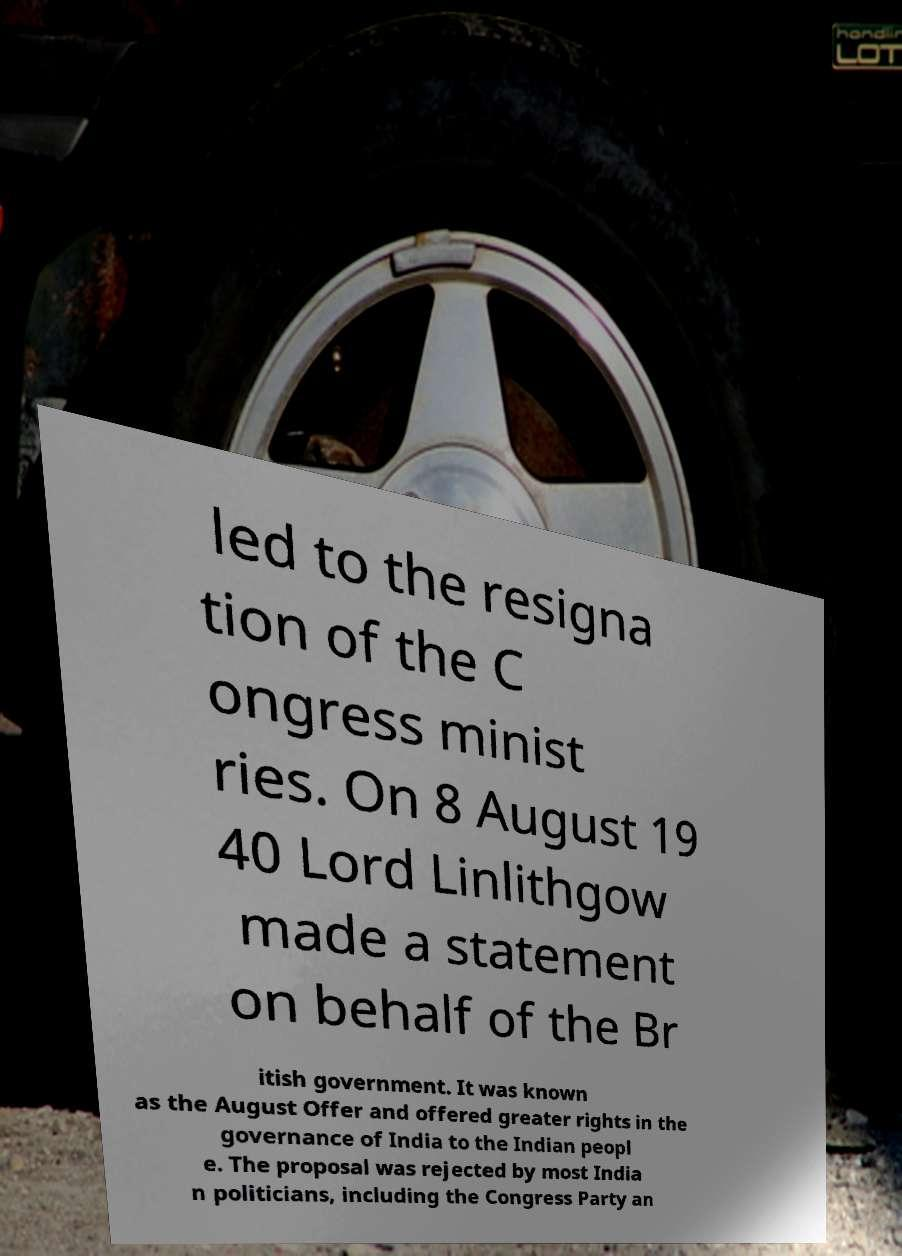What messages or text are displayed in this image? I need them in a readable, typed format. led to the resigna tion of the C ongress minist ries. On 8 August 19 40 Lord Linlithgow made a statement on behalf of the Br itish government. It was known as the August Offer and offered greater rights in the governance of India to the Indian peopl e. The proposal was rejected by most India n politicians, including the Congress Party an 